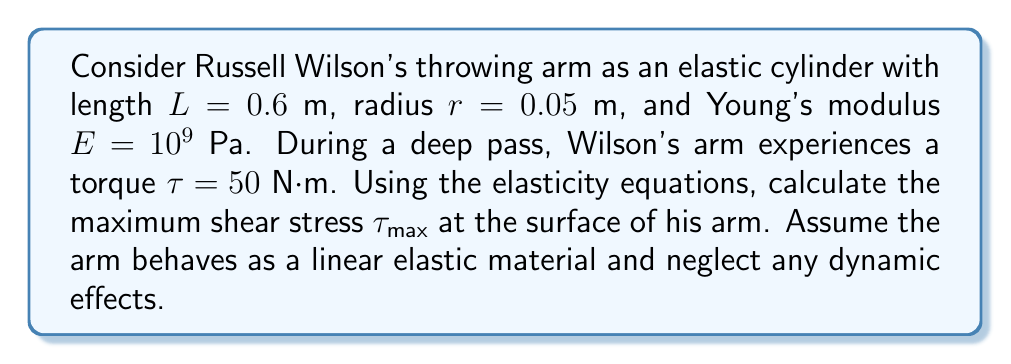Can you answer this question? To solve this problem, we'll use the elasticity equations for a cylindrical beam under torsion. The steps are as follows:

1) The maximum shear stress in a circular cross-section under torsion occurs at the surface and is given by:

   $$\tau_{max} = \frac{T r}{J}$$

   where $T$ is the applied torque, $r$ is the radius, and $J$ is the polar moment of inertia.

2) For a solid circular cross-section, the polar moment of inertia $J$ is:

   $$J = \frac{\pi r^4}{2}$$

3) Substituting the given values:
   
   $T = 50$ N⋅m
   $r = 0.05$ m
   
   $$J = \frac{\pi (0.05\text{ m})^4}{2} = 9.8175 \times 10^{-8} \text{ m}^4$$

4) Now we can calculate the maximum shear stress:

   $$\tau_{max} = \frac{(50\text{ N⋅m})(0.05\text{ m})}{9.8175 \times 10^{-8} \text{ m}^4}$$

5) Simplifying:

   $$\tau_{max} = 2.5464 \times 10^6 \text{ Pa} = 2.5464 \text{ MPa}$$

This result represents the maximum shear stress experienced at the surface of Russell Wilson's arm during the throw, assuming it behaves as a linear elastic cylinder.
Answer: $\tau_{max} = 2.5464 \text{ MPa}$ 